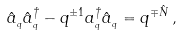Convert formula to latex. <formula><loc_0><loc_0><loc_500><loc_500>\hat { a } _ { _ { q } } \hat { a } _ { _ { q } } ^ { \dagger } - q ^ { \pm 1 } a _ { _ { q } } ^ { \dagger } \hat { a } _ { _ { q } } = q ^ { \mp \hat { N } } \, ,</formula> 